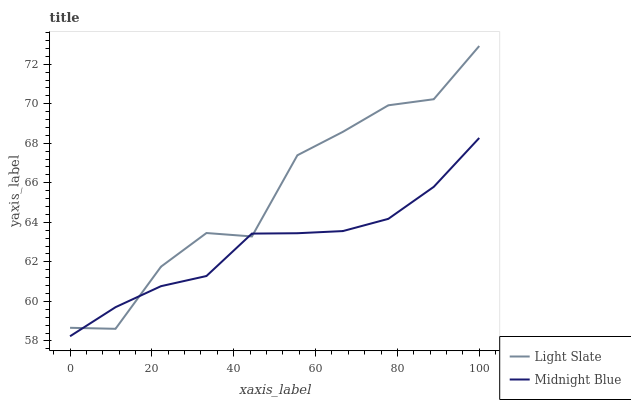Does Midnight Blue have the minimum area under the curve?
Answer yes or no. Yes. Does Light Slate have the maximum area under the curve?
Answer yes or no. Yes. Does Midnight Blue have the maximum area under the curve?
Answer yes or no. No. Is Midnight Blue the smoothest?
Answer yes or no. Yes. Is Light Slate the roughest?
Answer yes or no. Yes. Is Midnight Blue the roughest?
Answer yes or no. No. Does Midnight Blue have the lowest value?
Answer yes or no. Yes. Does Light Slate have the highest value?
Answer yes or no. Yes. Does Midnight Blue have the highest value?
Answer yes or no. No. Does Midnight Blue intersect Light Slate?
Answer yes or no. Yes. Is Midnight Blue less than Light Slate?
Answer yes or no. No. Is Midnight Blue greater than Light Slate?
Answer yes or no. No. 